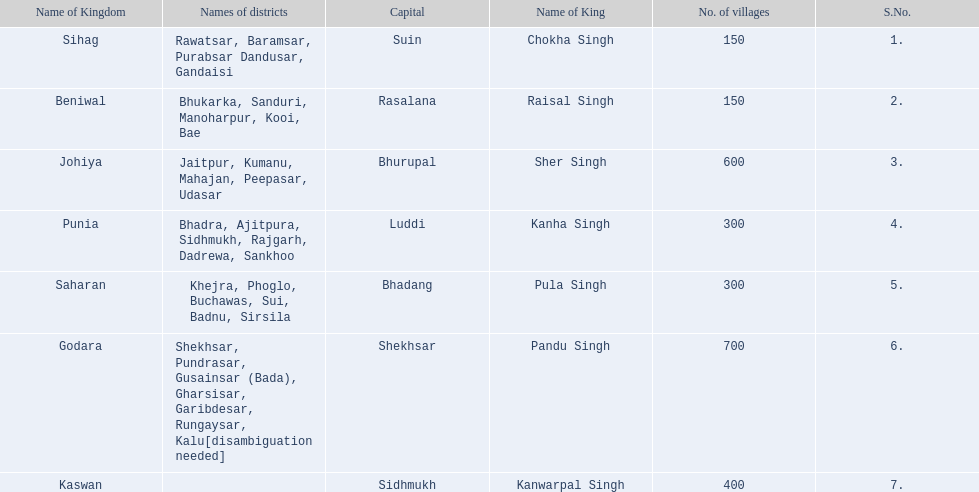What are all of the kingdoms? Sihag, Beniwal, Johiya, Punia, Saharan, Godara, Kaswan. How many villages do they contain? 150, 150, 600, 300, 300, 700, 400. How many are in godara? 700. Which kingdom comes next in highest amount of villages? Johiya. 